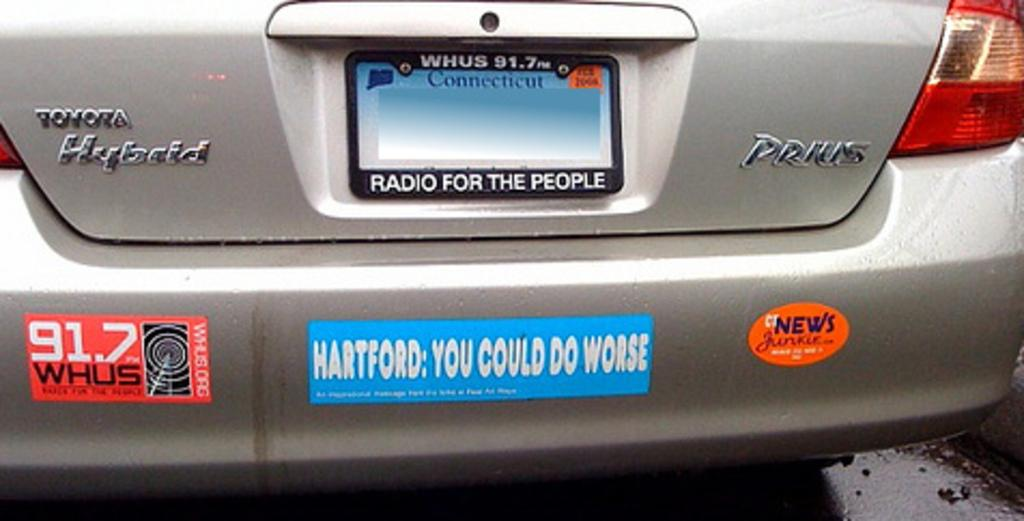<image>
Write a terse but informative summary of the picture. The back of a Hybrid Prius car from Connecticut that has several bumper stickers on it. 